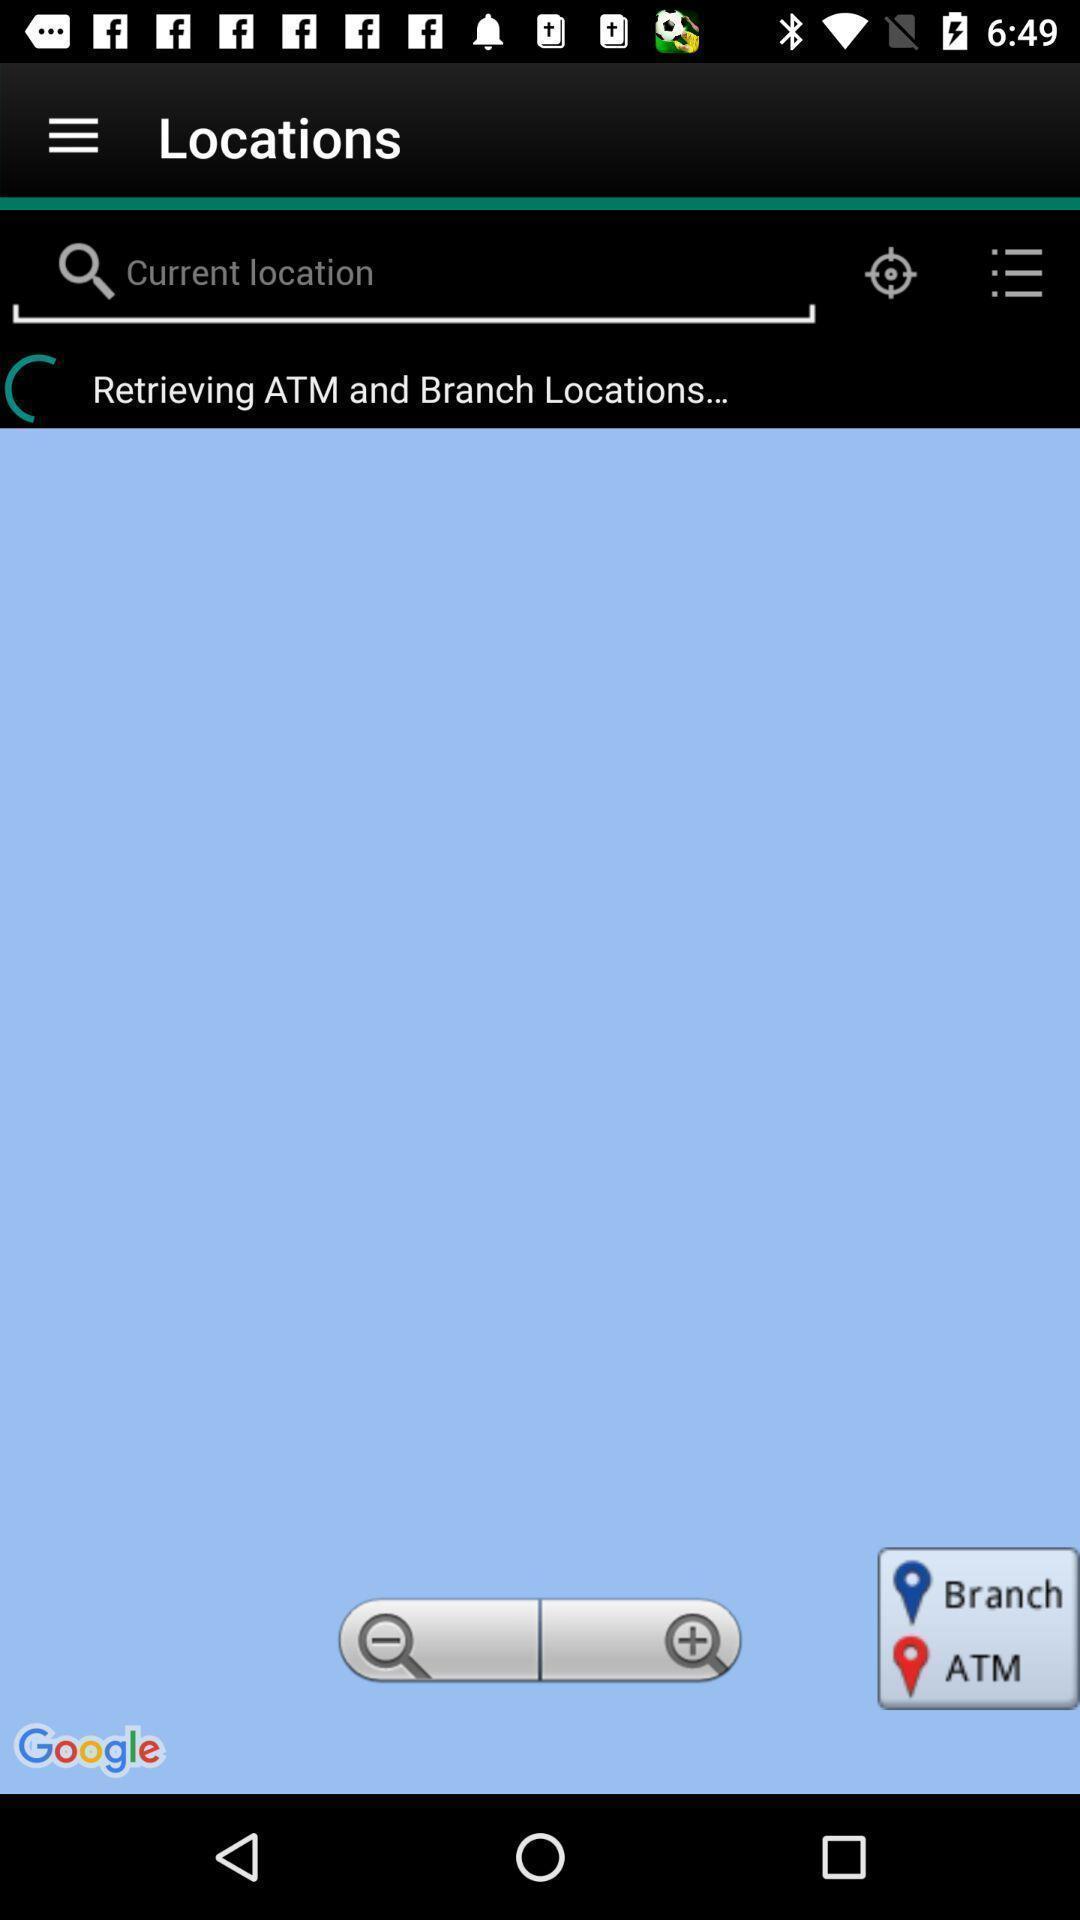What can you discern from this picture? Search for atm and branch locations. 